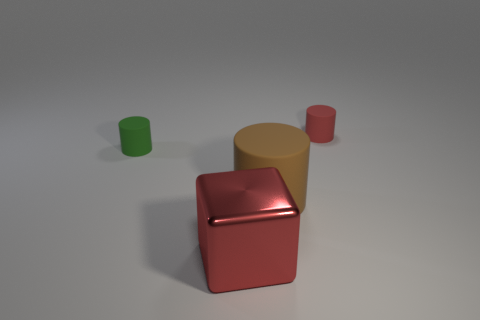What materials appear to be used in the objects within the image? The objects in the image appear to be made of plastic with a matte finish. There's a contrast between the textures of the objects and the glossy surface they rest upon, suggesting different materials at play. 